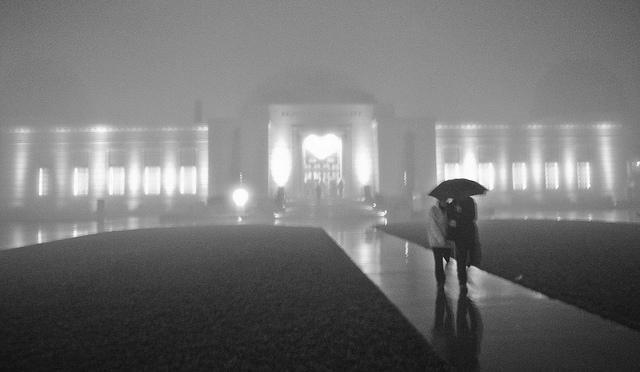What time of day is it?

Choices:
A) midnight
B) dusk
C) noon
D) mid morning dusk 